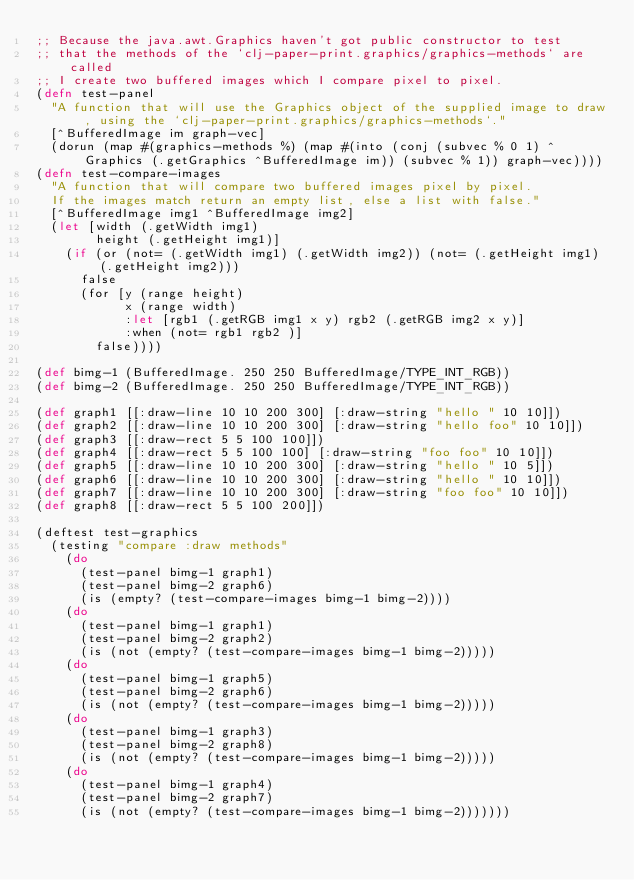Convert code to text. <code><loc_0><loc_0><loc_500><loc_500><_Clojure_>;; Because the java.awt.Graphics haven't got public constructor to test
;; that the methods of the `clj-paper-print.graphics/graphics-methods` are called
;; I create two buffered images which I compare pixel to pixel.
(defn test-panel
  "A function that will use the Graphics object of the supplied image to draw, using the `clj-paper-print.graphics/graphics-methods`."
  [^BufferedImage im graph-vec]
  (dorun (map #(graphics-methods %) (map #(into (conj (subvec % 0 1) ^Graphics (.getGraphics ^BufferedImage im)) (subvec % 1)) graph-vec))))
(defn test-compare-images
  "A function that will compare two buffered images pixel by pixel.
  If the images match return an empty list, else a list with false."
  [^BufferedImage img1 ^BufferedImage img2]
  (let [width (.getWidth img1)
        height (.getHeight img1)]
    (if (or (not= (.getWidth img1) (.getWidth img2)) (not= (.getHeight img1) (.getHeight img2)))
      false
      (for [y (range height)
            x (range width)
            :let [rgb1 (.getRGB img1 x y) rgb2 (.getRGB img2 x y)]
            :when (not= rgb1 rgb2 )]
        false))))

(def bimg-1 (BufferedImage. 250 250 BufferedImage/TYPE_INT_RGB))
(def bimg-2 (BufferedImage. 250 250 BufferedImage/TYPE_INT_RGB))

(def graph1 [[:draw-line 10 10 200 300] [:draw-string "hello " 10 10]])
(def graph2 [[:draw-line 10 10 200 300] [:draw-string "hello foo" 10 10]])
(def graph3 [[:draw-rect 5 5 100 100]])
(def graph4 [[:draw-rect 5 5 100 100] [:draw-string "foo foo" 10 10]])
(def graph5 [[:draw-line 10 10 200 300] [:draw-string "hello " 10 5]])
(def graph6 [[:draw-line 10 10 200 300] [:draw-string "hello " 10 10]])
(def graph7 [[:draw-line 10 10 200 300] [:draw-string "foo foo" 10 10]])
(def graph8 [[:draw-rect 5 5 100 200]])

(deftest test-graphics
  (testing "compare :draw methods"
    (do
      (test-panel bimg-1 graph1)
      (test-panel bimg-2 graph6)
      (is (empty? (test-compare-images bimg-1 bimg-2))))
    (do
      (test-panel bimg-1 graph1)
      (test-panel bimg-2 graph2)
      (is (not (empty? (test-compare-images bimg-1 bimg-2)))))
    (do
      (test-panel bimg-1 graph5)
      (test-panel bimg-2 graph6)
      (is (not (empty? (test-compare-images bimg-1 bimg-2)))))
    (do
      (test-panel bimg-1 graph3)
      (test-panel bimg-2 graph8)
      (is (not (empty? (test-compare-images bimg-1 bimg-2)))))
    (do
      (test-panel bimg-1 graph4)
      (test-panel bimg-2 graph7)
      (is (not (empty? (test-compare-images bimg-1 bimg-2)))))))

</code> 